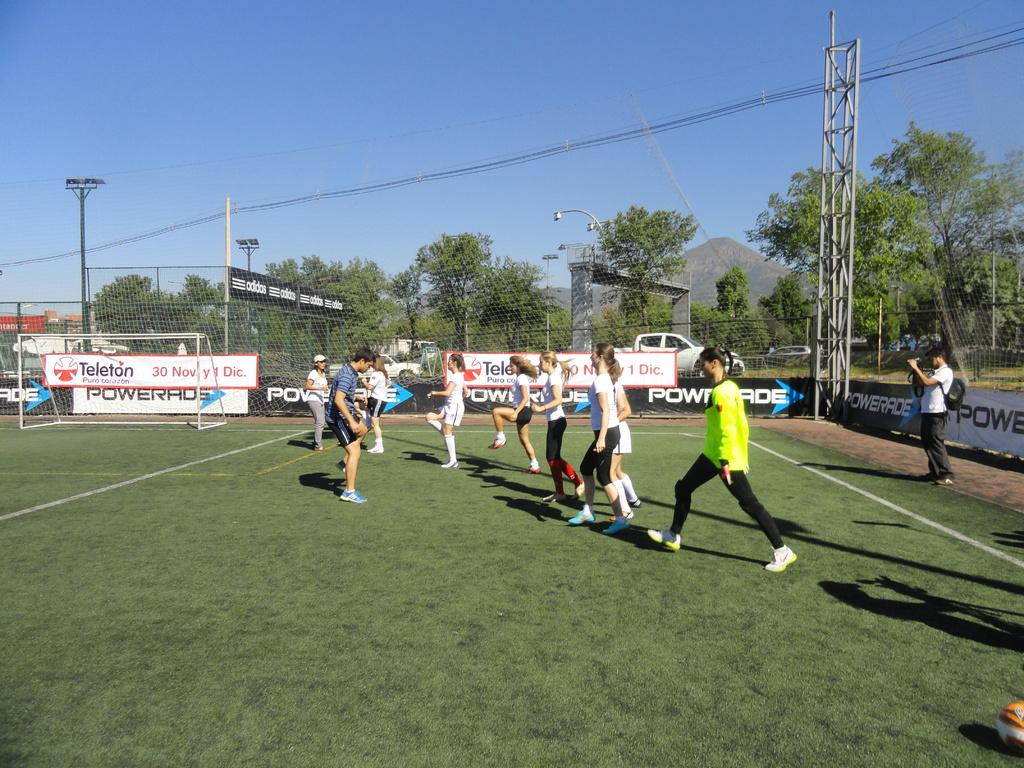<image>
Give a short and clear explanation of the subsequent image. A banner behind the soccer goal says Teleton and has a November date on it. 